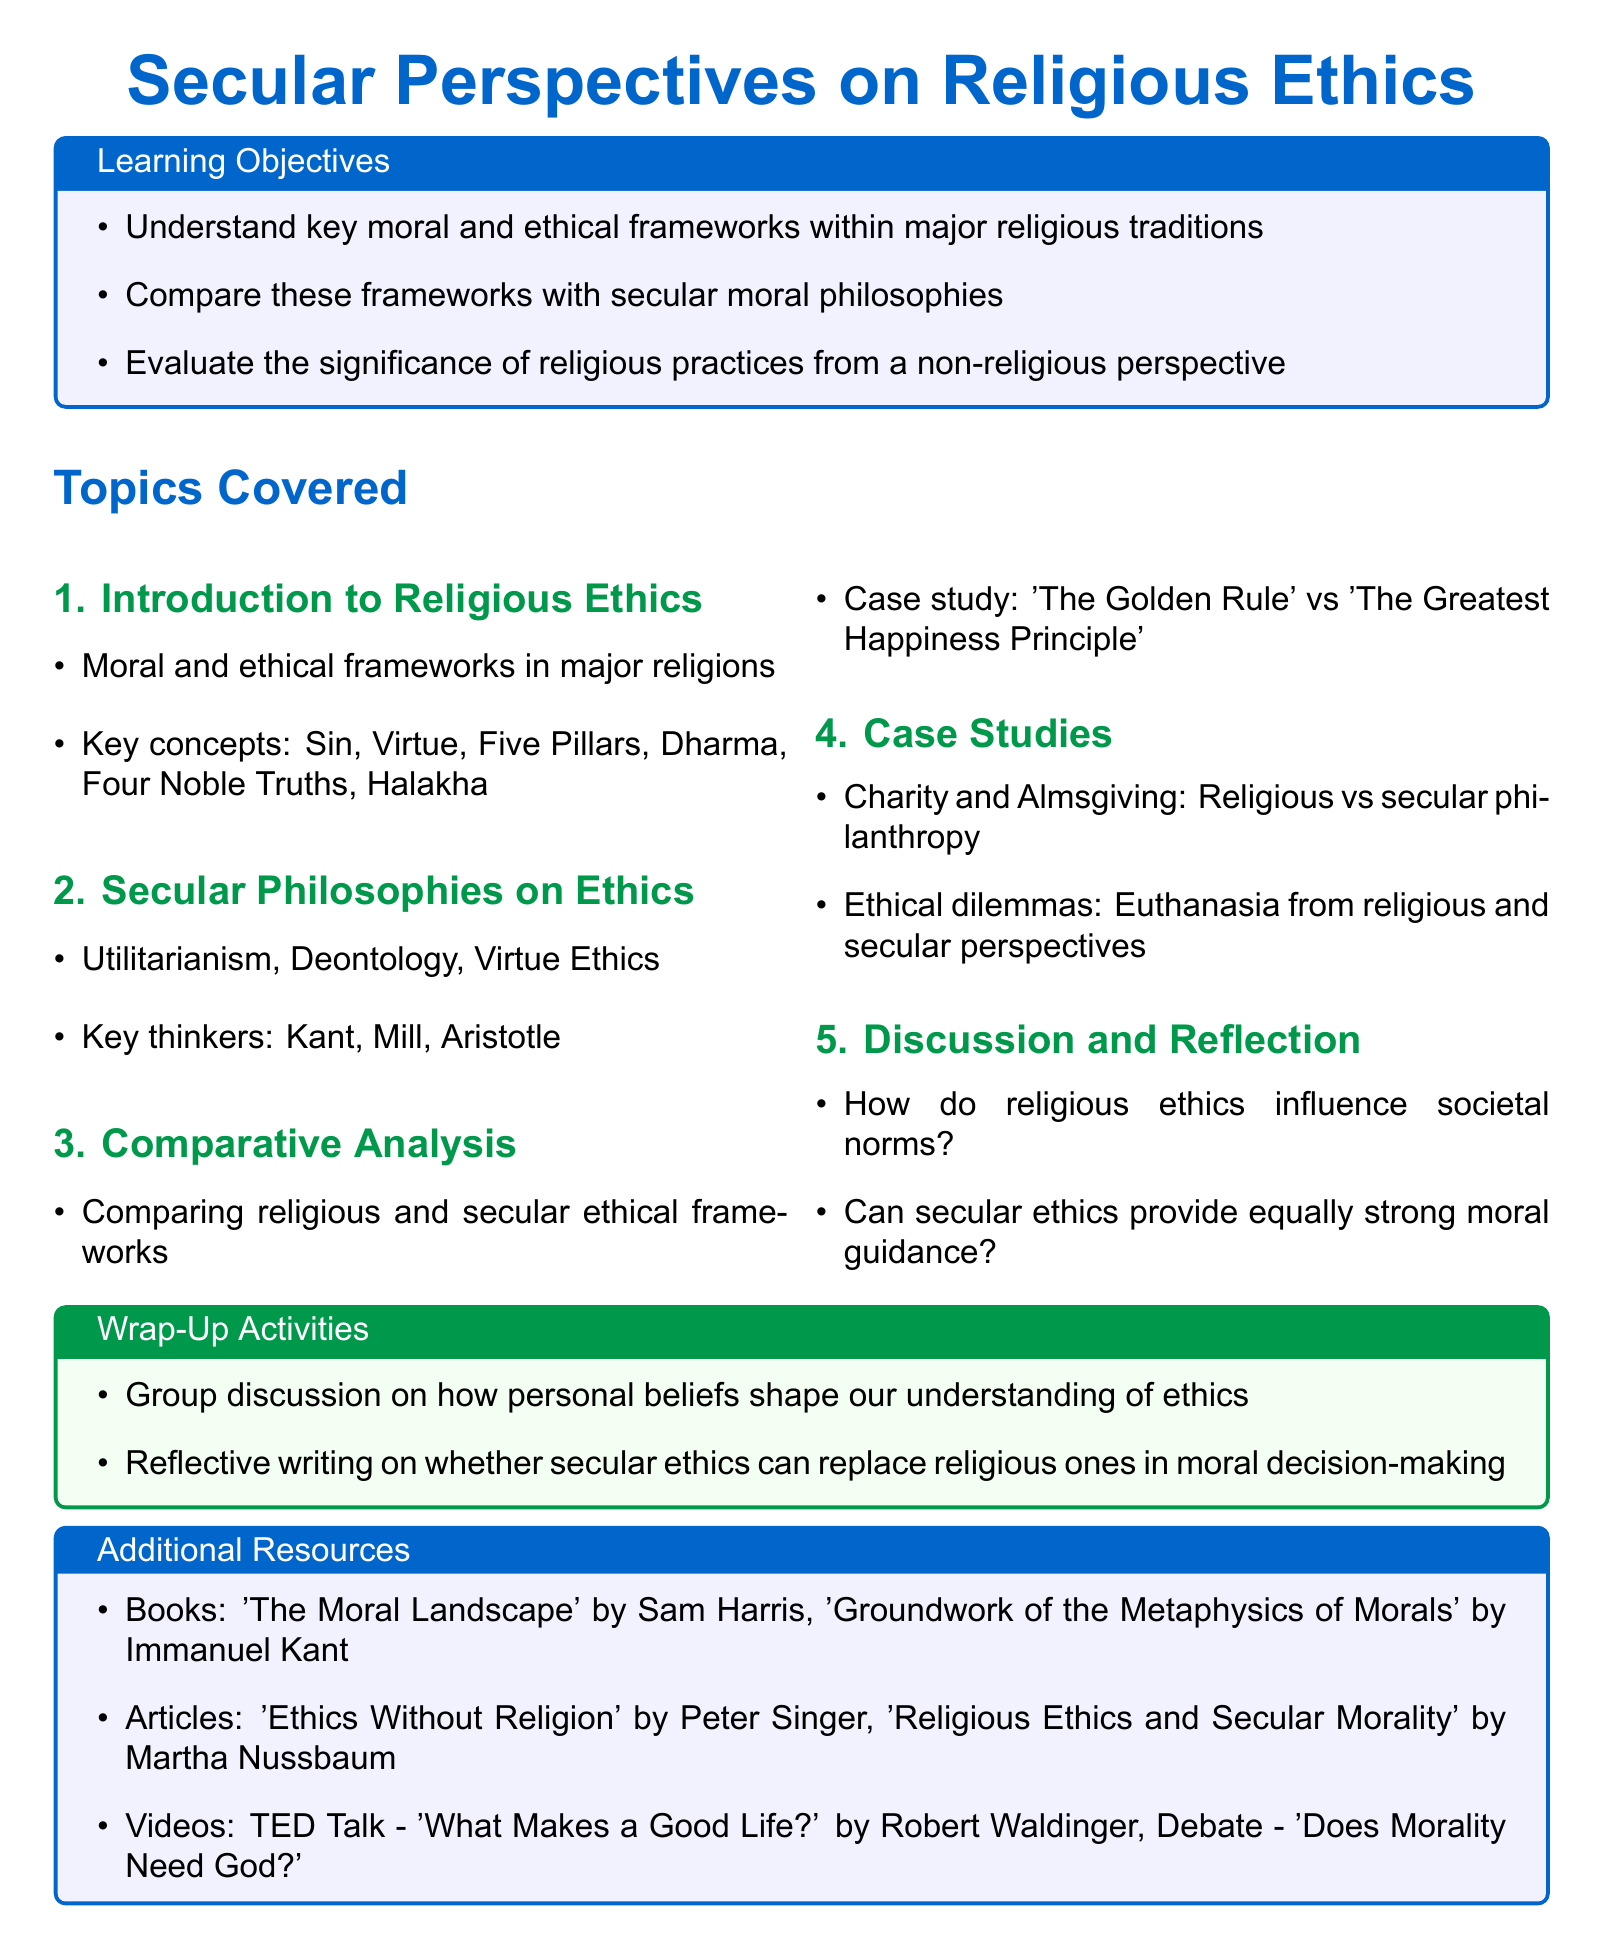What are the learning objectives? The learning objectives are found in the tcolorbox section of the document. They outline the key goals of the lesson plan.
Answer: Understand key moral and ethical frameworks within major religious traditions, Compare these frameworks with secular moral philosophies, Evaluate the significance of religious practices from a non-religious perspective Name one key thinker in secular philosophies on ethics. This information is provided in the second subsection, which lists notable figures associated with secular ethics.
Answer: Kant What is the total number of topics covered in the lesson plan? The document lists the number of subsections under the "Topics Covered" section, which includes five key areas of focus.
Answer: 5 What ethical dilemma is addressed in the case studies? The ethical dilemmas are outlined in the case studies section, specifically highlighting different views on certain moral issues.
Answer: Euthanasia What is one book recommended as an additional resource? The document in the additional resources section provides titles of books and articles related to the lesson topic.
Answer: 'The Moral Landscape' by Sam Harris How does the document suggest concluding the lesson? The wrap-up activities at the end of the document provide insight into how the lesson should be concluded.
Answer: Group discussion on how personal beliefs shape our understanding of ethics What is the color of the tcolorbox for Wrap-Up Activities? The tcolorbox colors are mentioned in the document, specifically indicated for different sections.
Answer: green!5 